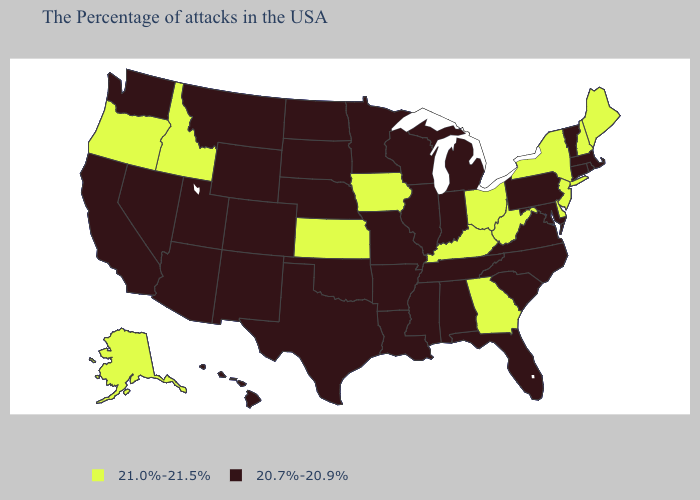Among the states that border Colorado , which have the highest value?
Short answer required. Kansas. Name the states that have a value in the range 21.0%-21.5%?
Write a very short answer. Maine, New Hampshire, New York, New Jersey, Delaware, West Virginia, Ohio, Georgia, Kentucky, Iowa, Kansas, Idaho, Oregon, Alaska. Does Kentucky have a higher value than Oregon?
Write a very short answer. No. Which states hav the highest value in the West?
Quick response, please. Idaho, Oregon, Alaska. Which states have the highest value in the USA?
Write a very short answer. Maine, New Hampshire, New York, New Jersey, Delaware, West Virginia, Ohio, Georgia, Kentucky, Iowa, Kansas, Idaho, Oregon, Alaska. What is the value of Maryland?
Give a very brief answer. 20.7%-20.9%. Name the states that have a value in the range 20.7%-20.9%?
Quick response, please. Massachusetts, Rhode Island, Vermont, Connecticut, Maryland, Pennsylvania, Virginia, North Carolina, South Carolina, Florida, Michigan, Indiana, Alabama, Tennessee, Wisconsin, Illinois, Mississippi, Louisiana, Missouri, Arkansas, Minnesota, Nebraska, Oklahoma, Texas, South Dakota, North Dakota, Wyoming, Colorado, New Mexico, Utah, Montana, Arizona, Nevada, California, Washington, Hawaii. What is the lowest value in states that border Vermont?
Answer briefly. 20.7%-20.9%. Name the states that have a value in the range 21.0%-21.5%?
Short answer required. Maine, New Hampshire, New York, New Jersey, Delaware, West Virginia, Ohio, Georgia, Kentucky, Iowa, Kansas, Idaho, Oregon, Alaska. Does the map have missing data?
Answer briefly. No. Name the states that have a value in the range 21.0%-21.5%?
Write a very short answer. Maine, New Hampshire, New York, New Jersey, Delaware, West Virginia, Ohio, Georgia, Kentucky, Iowa, Kansas, Idaho, Oregon, Alaska. What is the value of Arkansas?
Answer briefly. 20.7%-20.9%. Does Delaware have the highest value in the South?
Concise answer only. Yes. Does the map have missing data?
Keep it brief. No. What is the lowest value in the MidWest?
Give a very brief answer. 20.7%-20.9%. 